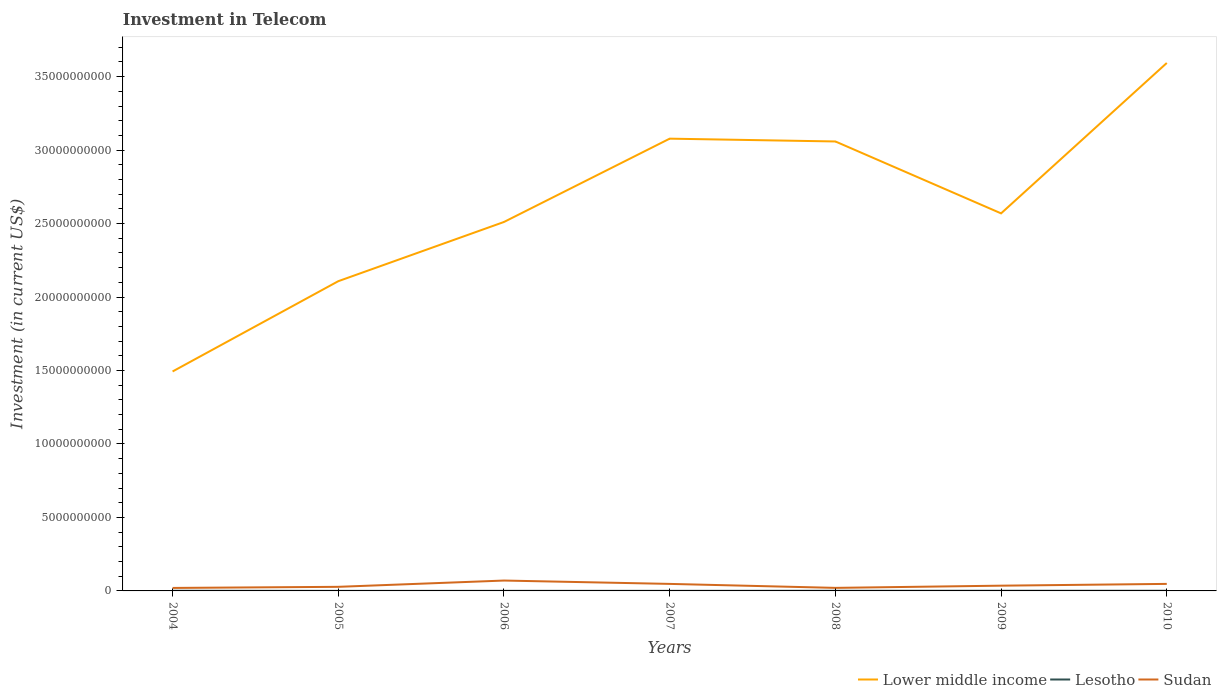Does the line corresponding to Sudan intersect with the line corresponding to Lesotho?
Provide a short and direct response. No. Is the number of lines equal to the number of legend labels?
Your answer should be very brief. Yes. Across all years, what is the maximum amount invested in telecom in Sudan?
Provide a short and direct response. 2.03e+08. What is the total amount invested in telecom in Lower middle income in the graph?
Offer a very short reply. -5.48e+09. What is the difference between the highest and the second highest amount invested in telecom in Lower middle income?
Keep it short and to the point. 2.10e+1. What is the difference between the highest and the lowest amount invested in telecom in Lower middle income?
Keep it short and to the point. 3. How many lines are there?
Your answer should be very brief. 3. What is the difference between two consecutive major ticks on the Y-axis?
Provide a short and direct response. 5.00e+09. Does the graph contain any zero values?
Offer a very short reply. No. Where does the legend appear in the graph?
Ensure brevity in your answer.  Bottom right. How are the legend labels stacked?
Provide a succinct answer. Horizontal. What is the title of the graph?
Your response must be concise. Investment in Telecom. What is the label or title of the Y-axis?
Provide a succinct answer. Investment (in current US$). What is the Investment (in current US$) of Lower middle income in 2004?
Your answer should be very brief. 1.49e+1. What is the Investment (in current US$) in Lesotho in 2004?
Offer a very short reply. 1.15e+07. What is the Investment (in current US$) of Sudan in 2004?
Provide a short and direct response. 2.03e+08. What is the Investment (in current US$) of Lower middle income in 2005?
Your answer should be very brief. 2.11e+1. What is the Investment (in current US$) of Sudan in 2005?
Your answer should be compact. 2.78e+08. What is the Investment (in current US$) of Lower middle income in 2006?
Your answer should be very brief. 2.51e+1. What is the Investment (in current US$) of Lesotho in 2006?
Your response must be concise. 5.53e+06. What is the Investment (in current US$) in Sudan in 2006?
Provide a succinct answer. 7.06e+08. What is the Investment (in current US$) of Lower middle income in 2007?
Provide a succinct answer. 3.08e+1. What is the Investment (in current US$) of Lesotho in 2007?
Provide a succinct answer. 4.80e+06. What is the Investment (in current US$) of Sudan in 2007?
Your answer should be very brief. 4.78e+08. What is the Investment (in current US$) in Lower middle income in 2008?
Provide a short and direct response. 3.06e+1. What is the Investment (in current US$) in Lesotho in 2008?
Offer a terse response. 9.30e+06. What is the Investment (in current US$) of Sudan in 2008?
Your answer should be compact. 2.07e+08. What is the Investment (in current US$) in Lower middle income in 2009?
Offer a terse response. 2.57e+1. What is the Investment (in current US$) in Lesotho in 2009?
Your answer should be very brief. 1.10e+07. What is the Investment (in current US$) in Sudan in 2009?
Keep it short and to the point. 3.57e+08. What is the Investment (in current US$) in Lower middle income in 2010?
Keep it short and to the point. 3.59e+1. What is the Investment (in current US$) in Lesotho in 2010?
Your answer should be compact. 1.10e+07. What is the Investment (in current US$) of Sudan in 2010?
Offer a very short reply. 4.78e+08. Across all years, what is the maximum Investment (in current US$) in Lower middle income?
Give a very brief answer. 3.59e+1. Across all years, what is the maximum Investment (in current US$) of Lesotho?
Provide a short and direct response. 1.15e+07. Across all years, what is the maximum Investment (in current US$) in Sudan?
Your answer should be very brief. 7.06e+08. Across all years, what is the minimum Investment (in current US$) of Lower middle income?
Offer a very short reply. 1.49e+1. Across all years, what is the minimum Investment (in current US$) of Sudan?
Offer a very short reply. 2.03e+08. What is the total Investment (in current US$) in Lower middle income in the graph?
Keep it short and to the point. 1.84e+11. What is the total Investment (in current US$) of Lesotho in the graph?
Your response must be concise. 5.61e+07. What is the total Investment (in current US$) in Sudan in the graph?
Give a very brief answer. 2.71e+09. What is the difference between the Investment (in current US$) of Lower middle income in 2004 and that in 2005?
Ensure brevity in your answer.  -6.14e+09. What is the difference between the Investment (in current US$) of Lesotho in 2004 and that in 2005?
Give a very brief answer. 8.50e+06. What is the difference between the Investment (in current US$) in Sudan in 2004 and that in 2005?
Provide a succinct answer. -7.55e+07. What is the difference between the Investment (in current US$) in Lower middle income in 2004 and that in 2006?
Provide a short and direct response. -1.02e+1. What is the difference between the Investment (in current US$) in Lesotho in 2004 and that in 2006?
Give a very brief answer. 5.97e+06. What is the difference between the Investment (in current US$) in Sudan in 2004 and that in 2006?
Offer a very short reply. -5.03e+08. What is the difference between the Investment (in current US$) in Lower middle income in 2004 and that in 2007?
Ensure brevity in your answer.  -1.58e+1. What is the difference between the Investment (in current US$) of Lesotho in 2004 and that in 2007?
Your answer should be compact. 6.70e+06. What is the difference between the Investment (in current US$) in Sudan in 2004 and that in 2007?
Ensure brevity in your answer.  -2.75e+08. What is the difference between the Investment (in current US$) of Lower middle income in 2004 and that in 2008?
Your answer should be very brief. -1.57e+1. What is the difference between the Investment (in current US$) of Lesotho in 2004 and that in 2008?
Give a very brief answer. 2.20e+06. What is the difference between the Investment (in current US$) in Lower middle income in 2004 and that in 2009?
Provide a succinct answer. -1.08e+1. What is the difference between the Investment (in current US$) of Sudan in 2004 and that in 2009?
Keep it short and to the point. -1.54e+08. What is the difference between the Investment (in current US$) in Lower middle income in 2004 and that in 2010?
Your response must be concise. -2.10e+1. What is the difference between the Investment (in current US$) in Lesotho in 2004 and that in 2010?
Offer a very short reply. 5.00e+05. What is the difference between the Investment (in current US$) in Sudan in 2004 and that in 2010?
Make the answer very short. -2.75e+08. What is the difference between the Investment (in current US$) in Lower middle income in 2005 and that in 2006?
Offer a very short reply. -4.03e+09. What is the difference between the Investment (in current US$) in Lesotho in 2005 and that in 2006?
Give a very brief answer. -2.53e+06. What is the difference between the Investment (in current US$) in Sudan in 2005 and that in 2006?
Make the answer very short. -4.28e+08. What is the difference between the Investment (in current US$) in Lower middle income in 2005 and that in 2007?
Offer a terse response. -9.70e+09. What is the difference between the Investment (in current US$) of Lesotho in 2005 and that in 2007?
Your response must be concise. -1.80e+06. What is the difference between the Investment (in current US$) of Sudan in 2005 and that in 2007?
Your answer should be compact. -2.00e+08. What is the difference between the Investment (in current US$) in Lower middle income in 2005 and that in 2008?
Make the answer very short. -9.51e+09. What is the difference between the Investment (in current US$) of Lesotho in 2005 and that in 2008?
Keep it short and to the point. -6.30e+06. What is the difference between the Investment (in current US$) of Sudan in 2005 and that in 2008?
Your answer should be very brief. 7.15e+07. What is the difference between the Investment (in current US$) in Lower middle income in 2005 and that in 2009?
Provide a short and direct response. -4.62e+09. What is the difference between the Investment (in current US$) in Lesotho in 2005 and that in 2009?
Give a very brief answer. -8.00e+06. What is the difference between the Investment (in current US$) in Sudan in 2005 and that in 2009?
Ensure brevity in your answer.  -7.85e+07. What is the difference between the Investment (in current US$) of Lower middle income in 2005 and that in 2010?
Your answer should be very brief. -1.49e+1. What is the difference between the Investment (in current US$) in Lesotho in 2005 and that in 2010?
Your response must be concise. -8.00e+06. What is the difference between the Investment (in current US$) in Sudan in 2005 and that in 2010?
Offer a very short reply. -2.00e+08. What is the difference between the Investment (in current US$) in Lower middle income in 2006 and that in 2007?
Your answer should be compact. -5.67e+09. What is the difference between the Investment (in current US$) in Lesotho in 2006 and that in 2007?
Keep it short and to the point. 7.30e+05. What is the difference between the Investment (in current US$) in Sudan in 2006 and that in 2007?
Your answer should be very brief. 2.28e+08. What is the difference between the Investment (in current US$) of Lower middle income in 2006 and that in 2008?
Keep it short and to the point. -5.48e+09. What is the difference between the Investment (in current US$) of Lesotho in 2006 and that in 2008?
Ensure brevity in your answer.  -3.77e+06. What is the difference between the Investment (in current US$) in Sudan in 2006 and that in 2008?
Keep it short and to the point. 4.99e+08. What is the difference between the Investment (in current US$) of Lower middle income in 2006 and that in 2009?
Provide a succinct answer. -5.85e+08. What is the difference between the Investment (in current US$) of Lesotho in 2006 and that in 2009?
Give a very brief answer. -5.47e+06. What is the difference between the Investment (in current US$) of Sudan in 2006 and that in 2009?
Offer a terse response. 3.49e+08. What is the difference between the Investment (in current US$) in Lower middle income in 2006 and that in 2010?
Ensure brevity in your answer.  -1.08e+1. What is the difference between the Investment (in current US$) in Lesotho in 2006 and that in 2010?
Your response must be concise. -5.47e+06. What is the difference between the Investment (in current US$) in Sudan in 2006 and that in 2010?
Your answer should be compact. 2.28e+08. What is the difference between the Investment (in current US$) of Lower middle income in 2007 and that in 2008?
Keep it short and to the point. 1.91e+08. What is the difference between the Investment (in current US$) of Lesotho in 2007 and that in 2008?
Ensure brevity in your answer.  -4.50e+06. What is the difference between the Investment (in current US$) of Sudan in 2007 and that in 2008?
Give a very brief answer. 2.71e+08. What is the difference between the Investment (in current US$) in Lower middle income in 2007 and that in 2009?
Offer a very short reply. 5.09e+09. What is the difference between the Investment (in current US$) of Lesotho in 2007 and that in 2009?
Offer a terse response. -6.20e+06. What is the difference between the Investment (in current US$) of Sudan in 2007 and that in 2009?
Offer a terse response. 1.21e+08. What is the difference between the Investment (in current US$) of Lower middle income in 2007 and that in 2010?
Ensure brevity in your answer.  -5.15e+09. What is the difference between the Investment (in current US$) in Lesotho in 2007 and that in 2010?
Offer a very short reply. -6.20e+06. What is the difference between the Investment (in current US$) of Sudan in 2007 and that in 2010?
Give a very brief answer. 0. What is the difference between the Investment (in current US$) of Lower middle income in 2008 and that in 2009?
Offer a terse response. 4.89e+09. What is the difference between the Investment (in current US$) in Lesotho in 2008 and that in 2009?
Offer a terse response. -1.70e+06. What is the difference between the Investment (in current US$) of Sudan in 2008 and that in 2009?
Your response must be concise. -1.50e+08. What is the difference between the Investment (in current US$) of Lower middle income in 2008 and that in 2010?
Provide a short and direct response. -5.34e+09. What is the difference between the Investment (in current US$) in Lesotho in 2008 and that in 2010?
Give a very brief answer. -1.70e+06. What is the difference between the Investment (in current US$) of Sudan in 2008 and that in 2010?
Offer a terse response. -2.71e+08. What is the difference between the Investment (in current US$) of Lower middle income in 2009 and that in 2010?
Make the answer very short. -1.02e+1. What is the difference between the Investment (in current US$) in Sudan in 2009 and that in 2010?
Make the answer very short. -1.21e+08. What is the difference between the Investment (in current US$) in Lower middle income in 2004 and the Investment (in current US$) in Lesotho in 2005?
Your response must be concise. 1.49e+1. What is the difference between the Investment (in current US$) in Lower middle income in 2004 and the Investment (in current US$) in Sudan in 2005?
Provide a succinct answer. 1.47e+1. What is the difference between the Investment (in current US$) in Lesotho in 2004 and the Investment (in current US$) in Sudan in 2005?
Your response must be concise. -2.67e+08. What is the difference between the Investment (in current US$) of Lower middle income in 2004 and the Investment (in current US$) of Lesotho in 2006?
Provide a short and direct response. 1.49e+1. What is the difference between the Investment (in current US$) in Lower middle income in 2004 and the Investment (in current US$) in Sudan in 2006?
Provide a short and direct response. 1.42e+1. What is the difference between the Investment (in current US$) in Lesotho in 2004 and the Investment (in current US$) in Sudan in 2006?
Offer a very short reply. -6.95e+08. What is the difference between the Investment (in current US$) of Lower middle income in 2004 and the Investment (in current US$) of Lesotho in 2007?
Your response must be concise. 1.49e+1. What is the difference between the Investment (in current US$) in Lower middle income in 2004 and the Investment (in current US$) in Sudan in 2007?
Provide a succinct answer. 1.45e+1. What is the difference between the Investment (in current US$) in Lesotho in 2004 and the Investment (in current US$) in Sudan in 2007?
Make the answer very short. -4.66e+08. What is the difference between the Investment (in current US$) in Lower middle income in 2004 and the Investment (in current US$) in Lesotho in 2008?
Give a very brief answer. 1.49e+1. What is the difference between the Investment (in current US$) in Lower middle income in 2004 and the Investment (in current US$) in Sudan in 2008?
Make the answer very short. 1.47e+1. What is the difference between the Investment (in current US$) in Lesotho in 2004 and the Investment (in current US$) in Sudan in 2008?
Provide a short and direct response. -1.96e+08. What is the difference between the Investment (in current US$) of Lower middle income in 2004 and the Investment (in current US$) of Lesotho in 2009?
Your answer should be very brief. 1.49e+1. What is the difference between the Investment (in current US$) in Lower middle income in 2004 and the Investment (in current US$) in Sudan in 2009?
Offer a terse response. 1.46e+1. What is the difference between the Investment (in current US$) of Lesotho in 2004 and the Investment (in current US$) of Sudan in 2009?
Your answer should be compact. -3.46e+08. What is the difference between the Investment (in current US$) of Lower middle income in 2004 and the Investment (in current US$) of Lesotho in 2010?
Offer a terse response. 1.49e+1. What is the difference between the Investment (in current US$) of Lower middle income in 2004 and the Investment (in current US$) of Sudan in 2010?
Your answer should be very brief. 1.45e+1. What is the difference between the Investment (in current US$) of Lesotho in 2004 and the Investment (in current US$) of Sudan in 2010?
Keep it short and to the point. -4.66e+08. What is the difference between the Investment (in current US$) in Lower middle income in 2005 and the Investment (in current US$) in Lesotho in 2006?
Offer a terse response. 2.11e+1. What is the difference between the Investment (in current US$) of Lower middle income in 2005 and the Investment (in current US$) of Sudan in 2006?
Provide a succinct answer. 2.04e+1. What is the difference between the Investment (in current US$) of Lesotho in 2005 and the Investment (in current US$) of Sudan in 2006?
Ensure brevity in your answer.  -7.03e+08. What is the difference between the Investment (in current US$) of Lower middle income in 2005 and the Investment (in current US$) of Lesotho in 2007?
Provide a succinct answer. 2.11e+1. What is the difference between the Investment (in current US$) of Lower middle income in 2005 and the Investment (in current US$) of Sudan in 2007?
Your response must be concise. 2.06e+1. What is the difference between the Investment (in current US$) of Lesotho in 2005 and the Investment (in current US$) of Sudan in 2007?
Your answer should be compact. -4.75e+08. What is the difference between the Investment (in current US$) in Lower middle income in 2005 and the Investment (in current US$) in Lesotho in 2008?
Your answer should be compact. 2.11e+1. What is the difference between the Investment (in current US$) of Lower middle income in 2005 and the Investment (in current US$) of Sudan in 2008?
Provide a short and direct response. 2.09e+1. What is the difference between the Investment (in current US$) of Lesotho in 2005 and the Investment (in current US$) of Sudan in 2008?
Your answer should be compact. -2.04e+08. What is the difference between the Investment (in current US$) of Lower middle income in 2005 and the Investment (in current US$) of Lesotho in 2009?
Give a very brief answer. 2.11e+1. What is the difference between the Investment (in current US$) in Lower middle income in 2005 and the Investment (in current US$) in Sudan in 2009?
Your answer should be compact. 2.07e+1. What is the difference between the Investment (in current US$) in Lesotho in 2005 and the Investment (in current US$) in Sudan in 2009?
Keep it short and to the point. -3.54e+08. What is the difference between the Investment (in current US$) in Lower middle income in 2005 and the Investment (in current US$) in Lesotho in 2010?
Make the answer very short. 2.11e+1. What is the difference between the Investment (in current US$) of Lower middle income in 2005 and the Investment (in current US$) of Sudan in 2010?
Give a very brief answer. 2.06e+1. What is the difference between the Investment (in current US$) in Lesotho in 2005 and the Investment (in current US$) in Sudan in 2010?
Offer a terse response. -4.75e+08. What is the difference between the Investment (in current US$) in Lower middle income in 2006 and the Investment (in current US$) in Lesotho in 2007?
Provide a short and direct response. 2.51e+1. What is the difference between the Investment (in current US$) of Lower middle income in 2006 and the Investment (in current US$) of Sudan in 2007?
Provide a succinct answer. 2.46e+1. What is the difference between the Investment (in current US$) in Lesotho in 2006 and the Investment (in current US$) in Sudan in 2007?
Give a very brief answer. -4.72e+08. What is the difference between the Investment (in current US$) in Lower middle income in 2006 and the Investment (in current US$) in Lesotho in 2008?
Provide a short and direct response. 2.51e+1. What is the difference between the Investment (in current US$) in Lower middle income in 2006 and the Investment (in current US$) in Sudan in 2008?
Provide a short and direct response. 2.49e+1. What is the difference between the Investment (in current US$) of Lesotho in 2006 and the Investment (in current US$) of Sudan in 2008?
Make the answer very short. -2.01e+08. What is the difference between the Investment (in current US$) in Lower middle income in 2006 and the Investment (in current US$) in Lesotho in 2009?
Your response must be concise. 2.51e+1. What is the difference between the Investment (in current US$) in Lower middle income in 2006 and the Investment (in current US$) in Sudan in 2009?
Your answer should be very brief. 2.48e+1. What is the difference between the Investment (in current US$) in Lesotho in 2006 and the Investment (in current US$) in Sudan in 2009?
Ensure brevity in your answer.  -3.51e+08. What is the difference between the Investment (in current US$) in Lower middle income in 2006 and the Investment (in current US$) in Lesotho in 2010?
Keep it short and to the point. 2.51e+1. What is the difference between the Investment (in current US$) in Lower middle income in 2006 and the Investment (in current US$) in Sudan in 2010?
Provide a succinct answer. 2.46e+1. What is the difference between the Investment (in current US$) of Lesotho in 2006 and the Investment (in current US$) of Sudan in 2010?
Your answer should be very brief. -4.72e+08. What is the difference between the Investment (in current US$) of Lower middle income in 2007 and the Investment (in current US$) of Lesotho in 2008?
Provide a succinct answer. 3.08e+1. What is the difference between the Investment (in current US$) in Lower middle income in 2007 and the Investment (in current US$) in Sudan in 2008?
Ensure brevity in your answer.  3.06e+1. What is the difference between the Investment (in current US$) of Lesotho in 2007 and the Investment (in current US$) of Sudan in 2008?
Your response must be concise. -2.02e+08. What is the difference between the Investment (in current US$) in Lower middle income in 2007 and the Investment (in current US$) in Lesotho in 2009?
Offer a terse response. 3.08e+1. What is the difference between the Investment (in current US$) of Lower middle income in 2007 and the Investment (in current US$) of Sudan in 2009?
Ensure brevity in your answer.  3.04e+1. What is the difference between the Investment (in current US$) of Lesotho in 2007 and the Investment (in current US$) of Sudan in 2009?
Make the answer very short. -3.52e+08. What is the difference between the Investment (in current US$) in Lower middle income in 2007 and the Investment (in current US$) in Lesotho in 2010?
Provide a succinct answer. 3.08e+1. What is the difference between the Investment (in current US$) of Lower middle income in 2007 and the Investment (in current US$) of Sudan in 2010?
Provide a succinct answer. 3.03e+1. What is the difference between the Investment (in current US$) in Lesotho in 2007 and the Investment (in current US$) in Sudan in 2010?
Offer a terse response. -4.73e+08. What is the difference between the Investment (in current US$) in Lower middle income in 2008 and the Investment (in current US$) in Lesotho in 2009?
Make the answer very short. 3.06e+1. What is the difference between the Investment (in current US$) of Lower middle income in 2008 and the Investment (in current US$) of Sudan in 2009?
Keep it short and to the point. 3.02e+1. What is the difference between the Investment (in current US$) of Lesotho in 2008 and the Investment (in current US$) of Sudan in 2009?
Ensure brevity in your answer.  -3.48e+08. What is the difference between the Investment (in current US$) in Lower middle income in 2008 and the Investment (in current US$) in Lesotho in 2010?
Your answer should be compact. 3.06e+1. What is the difference between the Investment (in current US$) of Lower middle income in 2008 and the Investment (in current US$) of Sudan in 2010?
Provide a short and direct response. 3.01e+1. What is the difference between the Investment (in current US$) of Lesotho in 2008 and the Investment (in current US$) of Sudan in 2010?
Keep it short and to the point. -4.69e+08. What is the difference between the Investment (in current US$) of Lower middle income in 2009 and the Investment (in current US$) of Lesotho in 2010?
Keep it short and to the point. 2.57e+1. What is the difference between the Investment (in current US$) in Lower middle income in 2009 and the Investment (in current US$) in Sudan in 2010?
Offer a very short reply. 2.52e+1. What is the difference between the Investment (in current US$) in Lesotho in 2009 and the Investment (in current US$) in Sudan in 2010?
Provide a succinct answer. -4.67e+08. What is the average Investment (in current US$) in Lower middle income per year?
Give a very brief answer. 2.63e+1. What is the average Investment (in current US$) of Lesotho per year?
Keep it short and to the point. 8.02e+06. What is the average Investment (in current US$) in Sudan per year?
Your response must be concise. 3.87e+08. In the year 2004, what is the difference between the Investment (in current US$) in Lower middle income and Investment (in current US$) in Lesotho?
Offer a very short reply. 1.49e+1. In the year 2004, what is the difference between the Investment (in current US$) of Lower middle income and Investment (in current US$) of Sudan?
Keep it short and to the point. 1.47e+1. In the year 2004, what is the difference between the Investment (in current US$) in Lesotho and Investment (in current US$) in Sudan?
Your response must be concise. -1.92e+08. In the year 2005, what is the difference between the Investment (in current US$) of Lower middle income and Investment (in current US$) of Lesotho?
Give a very brief answer. 2.11e+1. In the year 2005, what is the difference between the Investment (in current US$) of Lower middle income and Investment (in current US$) of Sudan?
Provide a succinct answer. 2.08e+1. In the year 2005, what is the difference between the Investment (in current US$) in Lesotho and Investment (in current US$) in Sudan?
Your response must be concise. -2.76e+08. In the year 2006, what is the difference between the Investment (in current US$) in Lower middle income and Investment (in current US$) in Lesotho?
Your response must be concise. 2.51e+1. In the year 2006, what is the difference between the Investment (in current US$) of Lower middle income and Investment (in current US$) of Sudan?
Provide a short and direct response. 2.44e+1. In the year 2006, what is the difference between the Investment (in current US$) of Lesotho and Investment (in current US$) of Sudan?
Offer a very short reply. -7.01e+08. In the year 2007, what is the difference between the Investment (in current US$) of Lower middle income and Investment (in current US$) of Lesotho?
Offer a very short reply. 3.08e+1. In the year 2007, what is the difference between the Investment (in current US$) in Lower middle income and Investment (in current US$) in Sudan?
Make the answer very short. 3.03e+1. In the year 2007, what is the difference between the Investment (in current US$) in Lesotho and Investment (in current US$) in Sudan?
Provide a short and direct response. -4.73e+08. In the year 2008, what is the difference between the Investment (in current US$) in Lower middle income and Investment (in current US$) in Lesotho?
Offer a terse response. 3.06e+1. In the year 2008, what is the difference between the Investment (in current US$) of Lower middle income and Investment (in current US$) of Sudan?
Give a very brief answer. 3.04e+1. In the year 2008, what is the difference between the Investment (in current US$) of Lesotho and Investment (in current US$) of Sudan?
Provide a succinct answer. -1.98e+08. In the year 2009, what is the difference between the Investment (in current US$) in Lower middle income and Investment (in current US$) in Lesotho?
Provide a short and direct response. 2.57e+1. In the year 2009, what is the difference between the Investment (in current US$) of Lower middle income and Investment (in current US$) of Sudan?
Make the answer very short. 2.53e+1. In the year 2009, what is the difference between the Investment (in current US$) in Lesotho and Investment (in current US$) in Sudan?
Offer a terse response. -3.46e+08. In the year 2010, what is the difference between the Investment (in current US$) in Lower middle income and Investment (in current US$) in Lesotho?
Ensure brevity in your answer.  3.59e+1. In the year 2010, what is the difference between the Investment (in current US$) of Lower middle income and Investment (in current US$) of Sudan?
Offer a terse response. 3.55e+1. In the year 2010, what is the difference between the Investment (in current US$) of Lesotho and Investment (in current US$) of Sudan?
Keep it short and to the point. -4.67e+08. What is the ratio of the Investment (in current US$) of Lower middle income in 2004 to that in 2005?
Offer a very short reply. 0.71. What is the ratio of the Investment (in current US$) in Lesotho in 2004 to that in 2005?
Ensure brevity in your answer.  3.83. What is the ratio of the Investment (in current US$) in Sudan in 2004 to that in 2005?
Your response must be concise. 0.73. What is the ratio of the Investment (in current US$) of Lower middle income in 2004 to that in 2006?
Your answer should be compact. 0.59. What is the ratio of the Investment (in current US$) in Lesotho in 2004 to that in 2006?
Keep it short and to the point. 2.08. What is the ratio of the Investment (in current US$) of Sudan in 2004 to that in 2006?
Your answer should be very brief. 0.29. What is the ratio of the Investment (in current US$) in Lower middle income in 2004 to that in 2007?
Your response must be concise. 0.49. What is the ratio of the Investment (in current US$) in Lesotho in 2004 to that in 2007?
Your answer should be compact. 2.4. What is the ratio of the Investment (in current US$) in Sudan in 2004 to that in 2007?
Your response must be concise. 0.42. What is the ratio of the Investment (in current US$) in Lower middle income in 2004 to that in 2008?
Make the answer very short. 0.49. What is the ratio of the Investment (in current US$) in Lesotho in 2004 to that in 2008?
Your answer should be very brief. 1.24. What is the ratio of the Investment (in current US$) of Sudan in 2004 to that in 2008?
Your answer should be very brief. 0.98. What is the ratio of the Investment (in current US$) of Lower middle income in 2004 to that in 2009?
Your response must be concise. 0.58. What is the ratio of the Investment (in current US$) of Lesotho in 2004 to that in 2009?
Your answer should be compact. 1.05. What is the ratio of the Investment (in current US$) of Sudan in 2004 to that in 2009?
Your answer should be very brief. 0.57. What is the ratio of the Investment (in current US$) in Lower middle income in 2004 to that in 2010?
Give a very brief answer. 0.42. What is the ratio of the Investment (in current US$) of Lesotho in 2004 to that in 2010?
Give a very brief answer. 1.05. What is the ratio of the Investment (in current US$) of Sudan in 2004 to that in 2010?
Provide a short and direct response. 0.42. What is the ratio of the Investment (in current US$) of Lower middle income in 2005 to that in 2006?
Ensure brevity in your answer.  0.84. What is the ratio of the Investment (in current US$) in Lesotho in 2005 to that in 2006?
Make the answer very short. 0.54. What is the ratio of the Investment (in current US$) of Sudan in 2005 to that in 2006?
Provide a short and direct response. 0.39. What is the ratio of the Investment (in current US$) of Lower middle income in 2005 to that in 2007?
Offer a terse response. 0.68. What is the ratio of the Investment (in current US$) in Sudan in 2005 to that in 2007?
Your answer should be compact. 0.58. What is the ratio of the Investment (in current US$) in Lower middle income in 2005 to that in 2008?
Give a very brief answer. 0.69. What is the ratio of the Investment (in current US$) of Lesotho in 2005 to that in 2008?
Provide a succinct answer. 0.32. What is the ratio of the Investment (in current US$) of Sudan in 2005 to that in 2008?
Keep it short and to the point. 1.35. What is the ratio of the Investment (in current US$) of Lower middle income in 2005 to that in 2009?
Give a very brief answer. 0.82. What is the ratio of the Investment (in current US$) in Lesotho in 2005 to that in 2009?
Your answer should be compact. 0.27. What is the ratio of the Investment (in current US$) in Sudan in 2005 to that in 2009?
Provide a short and direct response. 0.78. What is the ratio of the Investment (in current US$) in Lower middle income in 2005 to that in 2010?
Make the answer very short. 0.59. What is the ratio of the Investment (in current US$) in Lesotho in 2005 to that in 2010?
Offer a terse response. 0.27. What is the ratio of the Investment (in current US$) in Sudan in 2005 to that in 2010?
Your response must be concise. 0.58. What is the ratio of the Investment (in current US$) in Lower middle income in 2006 to that in 2007?
Offer a very short reply. 0.82. What is the ratio of the Investment (in current US$) in Lesotho in 2006 to that in 2007?
Provide a succinct answer. 1.15. What is the ratio of the Investment (in current US$) of Sudan in 2006 to that in 2007?
Offer a terse response. 1.48. What is the ratio of the Investment (in current US$) of Lower middle income in 2006 to that in 2008?
Give a very brief answer. 0.82. What is the ratio of the Investment (in current US$) of Lesotho in 2006 to that in 2008?
Your answer should be very brief. 0.59. What is the ratio of the Investment (in current US$) in Sudan in 2006 to that in 2008?
Provide a succinct answer. 3.41. What is the ratio of the Investment (in current US$) of Lower middle income in 2006 to that in 2009?
Offer a very short reply. 0.98. What is the ratio of the Investment (in current US$) of Lesotho in 2006 to that in 2009?
Give a very brief answer. 0.5. What is the ratio of the Investment (in current US$) in Sudan in 2006 to that in 2009?
Your answer should be very brief. 1.98. What is the ratio of the Investment (in current US$) of Lower middle income in 2006 to that in 2010?
Offer a very short reply. 0.7. What is the ratio of the Investment (in current US$) of Lesotho in 2006 to that in 2010?
Ensure brevity in your answer.  0.5. What is the ratio of the Investment (in current US$) of Sudan in 2006 to that in 2010?
Give a very brief answer. 1.48. What is the ratio of the Investment (in current US$) in Lesotho in 2007 to that in 2008?
Keep it short and to the point. 0.52. What is the ratio of the Investment (in current US$) of Sudan in 2007 to that in 2008?
Provide a short and direct response. 2.31. What is the ratio of the Investment (in current US$) in Lower middle income in 2007 to that in 2009?
Give a very brief answer. 1.2. What is the ratio of the Investment (in current US$) in Lesotho in 2007 to that in 2009?
Make the answer very short. 0.44. What is the ratio of the Investment (in current US$) in Sudan in 2007 to that in 2009?
Your answer should be very brief. 1.34. What is the ratio of the Investment (in current US$) of Lower middle income in 2007 to that in 2010?
Your response must be concise. 0.86. What is the ratio of the Investment (in current US$) of Lesotho in 2007 to that in 2010?
Give a very brief answer. 0.44. What is the ratio of the Investment (in current US$) of Lower middle income in 2008 to that in 2009?
Offer a terse response. 1.19. What is the ratio of the Investment (in current US$) of Lesotho in 2008 to that in 2009?
Give a very brief answer. 0.85. What is the ratio of the Investment (in current US$) in Sudan in 2008 to that in 2009?
Make the answer very short. 0.58. What is the ratio of the Investment (in current US$) of Lower middle income in 2008 to that in 2010?
Offer a terse response. 0.85. What is the ratio of the Investment (in current US$) of Lesotho in 2008 to that in 2010?
Provide a short and direct response. 0.85. What is the ratio of the Investment (in current US$) of Sudan in 2008 to that in 2010?
Your answer should be compact. 0.43. What is the ratio of the Investment (in current US$) of Lower middle income in 2009 to that in 2010?
Provide a short and direct response. 0.72. What is the ratio of the Investment (in current US$) in Sudan in 2009 to that in 2010?
Provide a succinct answer. 0.75. What is the difference between the highest and the second highest Investment (in current US$) in Lower middle income?
Provide a short and direct response. 5.15e+09. What is the difference between the highest and the second highest Investment (in current US$) in Sudan?
Keep it short and to the point. 2.28e+08. What is the difference between the highest and the lowest Investment (in current US$) of Lower middle income?
Keep it short and to the point. 2.10e+1. What is the difference between the highest and the lowest Investment (in current US$) of Lesotho?
Your answer should be compact. 8.50e+06. What is the difference between the highest and the lowest Investment (in current US$) in Sudan?
Offer a very short reply. 5.03e+08. 